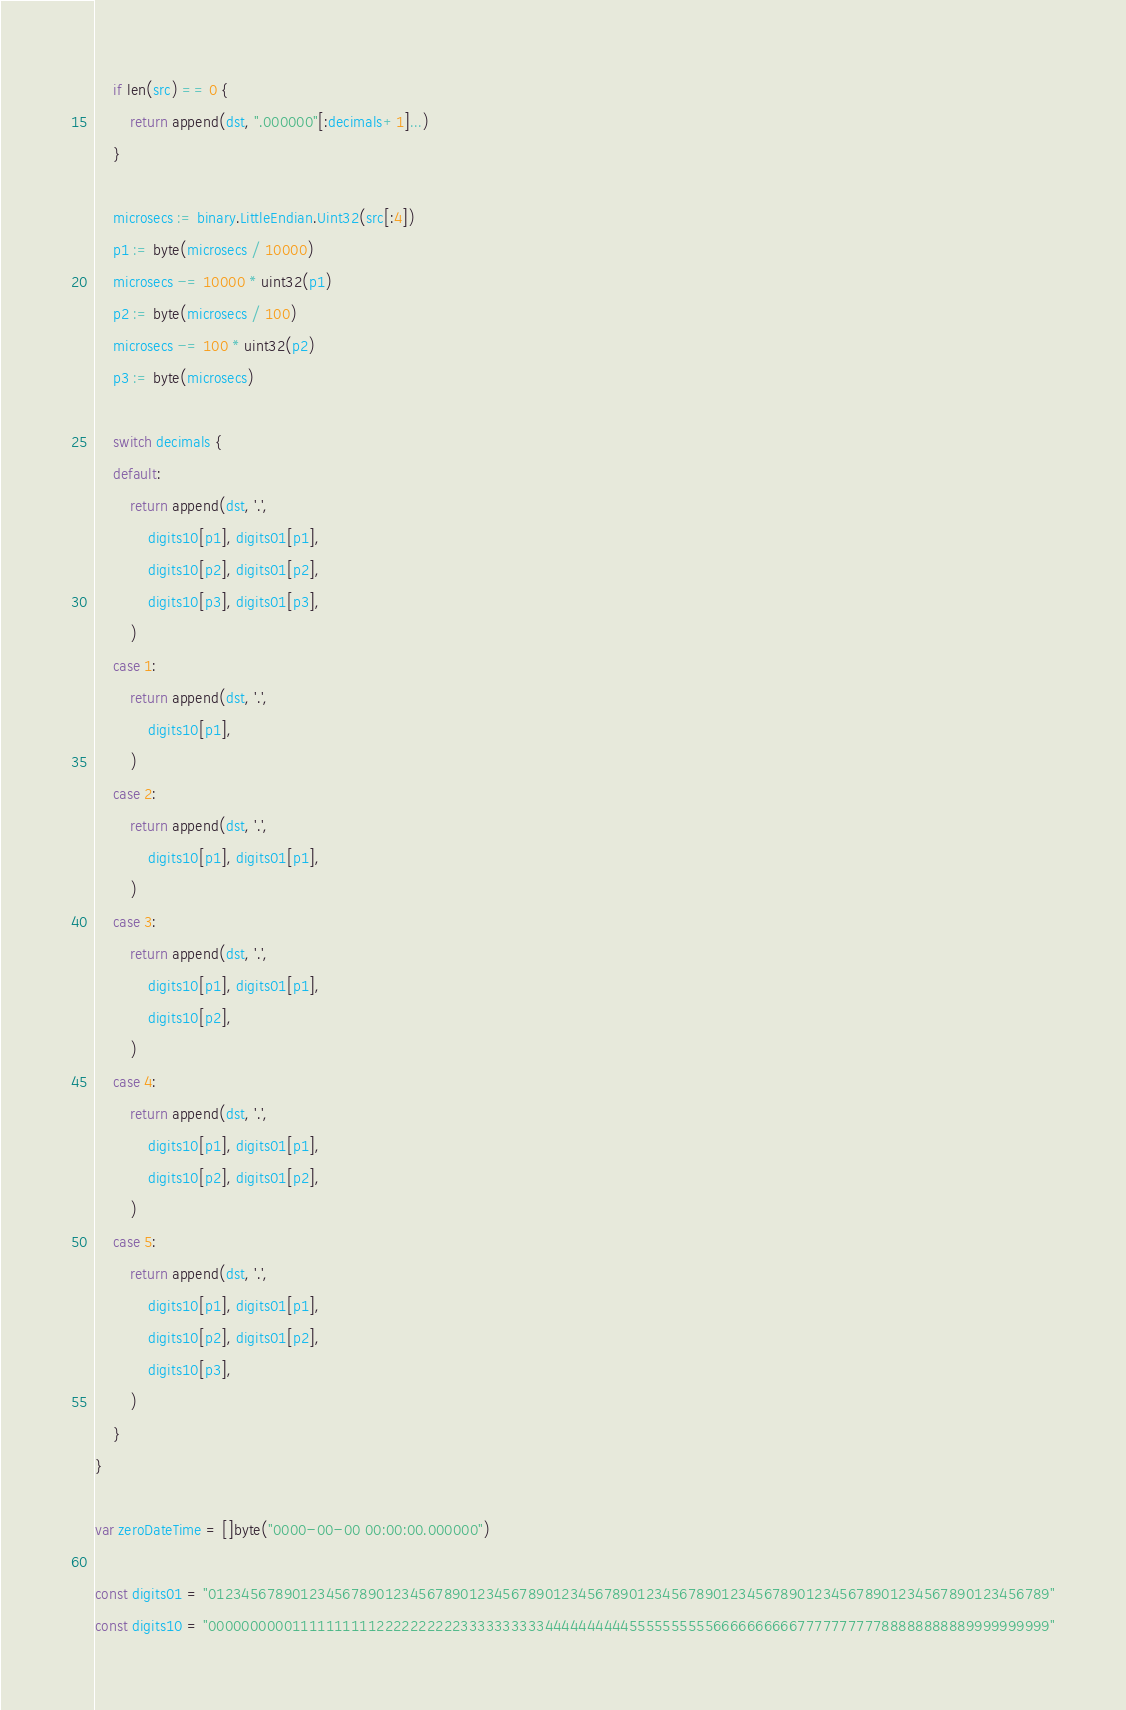<code> <loc_0><loc_0><loc_500><loc_500><_Go_>	if len(src) == 0 {
		return append(dst, ".000000"[:decimals+1]...)
	}

	microsecs := binary.LittleEndian.Uint32(src[:4])
	p1 := byte(microsecs / 10000)
	microsecs -= 10000 * uint32(p1)
	p2 := byte(microsecs / 100)
	microsecs -= 100 * uint32(p2)
	p3 := byte(microsecs)

	switch decimals {
	default:
		return append(dst, '.',
			digits10[p1], digits01[p1],
			digits10[p2], digits01[p2],
			digits10[p3], digits01[p3],
		)
	case 1:
		return append(dst, '.',
			digits10[p1],
		)
	case 2:
		return append(dst, '.',
			digits10[p1], digits01[p1],
		)
	case 3:
		return append(dst, '.',
			digits10[p1], digits01[p1],
			digits10[p2],
		)
	case 4:
		return append(dst, '.',
			digits10[p1], digits01[p1],
			digits10[p2], digits01[p2],
		)
	case 5:
		return append(dst, '.',
			digits10[p1], digits01[p1],
			digits10[p2], digits01[p2],
			digits10[p3],
		)
	}
}

var zeroDateTime = []byte("0000-00-00 00:00:00.000000")

const digits01 = "0123456789012345678901234567890123456789012345678901234567890123456789012345678901234567890123456789"
const digits10 = "0000000000111111111122222222223333333333444444444455555555556666666666777777777788888888889999999999"
</code> 